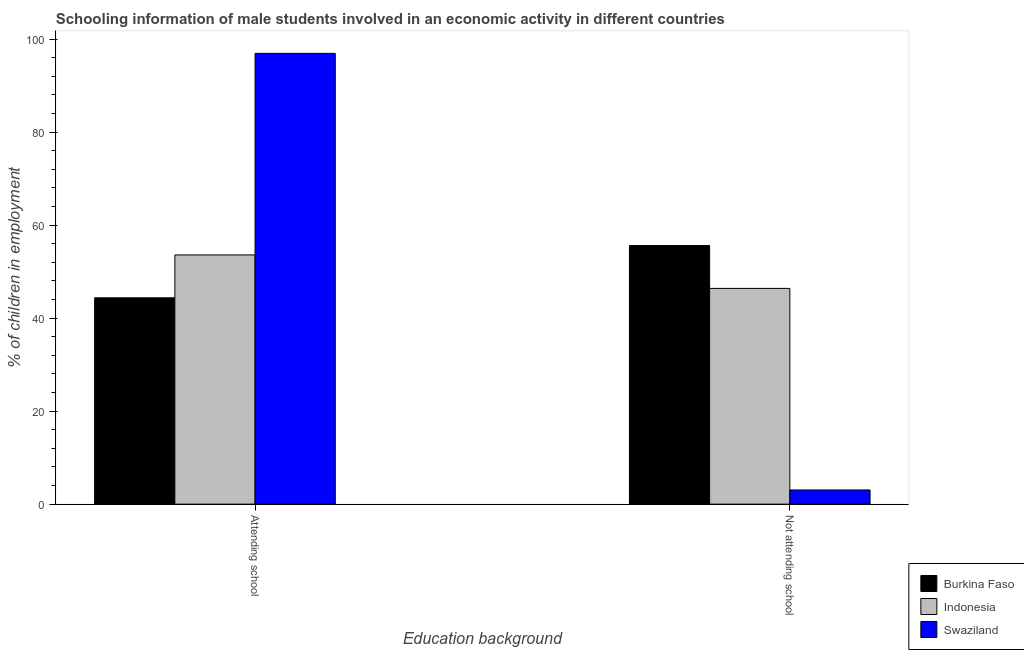How many different coloured bars are there?
Provide a short and direct response. 3. How many groups of bars are there?
Keep it short and to the point. 2. Are the number of bars per tick equal to the number of legend labels?
Your response must be concise. Yes. Are the number of bars on each tick of the X-axis equal?
Your response must be concise. Yes. How many bars are there on the 2nd tick from the left?
Your answer should be very brief. 3. What is the label of the 2nd group of bars from the left?
Your answer should be very brief. Not attending school. What is the percentage of employed males who are not attending school in Burkina Faso?
Offer a very short reply. 55.62. Across all countries, what is the maximum percentage of employed males who are attending school?
Keep it short and to the point. 96.95. Across all countries, what is the minimum percentage of employed males who are attending school?
Give a very brief answer. 44.38. In which country was the percentage of employed males who are attending school maximum?
Provide a succinct answer. Swaziland. In which country was the percentage of employed males who are attending school minimum?
Offer a terse response. Burkina Faso. What is the total percentage of employed males who are attending school in the graph?
Give a very brief answer. 194.93. What is the difference between the percentage of employed males who are not attending school in Indonesia and that in Swaziland?
Offer a terse response. 43.35. What is the difference between the percentage of employed males who are not attending school in Burkina Faso and the percentage of employed males who are attending school in Indonesia?
Provide a succinct answer. 2.02. What is the average percentage of employed males who are attending school per country?
Your response must be concise. 64.98. What is the difference between the percentage of employed males who are not attending school and percentage of employed males who are attending school in Swaziland?
Make the answer very short. -93.9. What is the ratio of the percentage of employed males who are not attending school in Burkina Faso to that in Indonesia?
Offer a very short reply. 1.2. Is the percentage of employed males who are not attending school in Indonesia less than that in Swaziland?
Give a very brief answer. No. What does the 3rd bar from the left in Attending school represents?
Provide a short and direct response. Swaziland. What does the 3rd bar from the right in Not attending school represents?
Ensure brevity in your answer.  Burkina Faso. How many bars are there?
Make the answer very short. 6. Are the values on the major ticks of Y-axis written in scientific E-notation?
Keep it short and to the point. No. Does the graph contain any zero values?
Your answer should be compact. No. Does the graph contain grids?
Your response must be concise. No. What is the title of the graph?
Offer a terse response. Schooling information of male students involved in an economic activity in different countries. Does "East Asia (all income levels)" appear as one of the legend labels in the graph?
Ensure brevity in your answer.  No. What is the label or title of the X-axis?
Give a very brief answer. Education background. What is the label or title of the Y-axis?
Your answer should be compact. % of children in employment. What is the % of children in employment in Burkina Faso in Attending school?
Ensure brevity in your answer.  44.38. What is the % of children in employment in Indonesia in Attending school?
Your response must be concise. 53.6. What is the % of children in employment in Swaziland in Attending school?
Provide a short and direct response. 96.95. What is the % of children in employment in Burkina Faso in Not attending school?
Your answer should be compact. 55.62. What is the % of children in employment of Indonesia in Not attending school?
Give a very brief answer. 46.4. What is the % of children in employment of Swaziland in Not attending school?
Your answer should be compact. 3.05. Across all Education background, what is the maximum % of children in employment in Burkina Faso?
Provide a succinct answer. 55.62. Across all Education background, what is the maximum % of children in employment of Indonesia?
Your answer should be very brief. 53.6. Across all Education background, what is the maximum % of children in employment of Swaziland?
Your response must be concise. 96.95. Across all Education background, what is the minimum % of children in employment in Burkina Faso?
Offer a very short reply. 44.38. Across all Education background, what is the minimum % of children in employment of Indonesia?
Ensure brevity in your answer.  46.4. Across all Education background, what is the minimum % of children in employment in Swaziland?
Give a very brief answer. 3.05. What is the total % of children in employment of Burkina Faso in the graph?
Offer a terse response. 100. What is the difference between the % of children in employment of Burkina Faso in Attending school and that in Not attending school?
Your response must be concise. -11.24. What is the difference between the % of children in employment in Swaziland in Attending school and that in Not attending school?
Ensure brevity in your answer.  93.9. What is the difference between the % of children in employment in Burkina Faso in Attending school and the % of children in employment in Indonesia in Not attending school?
Provide a succinct answer. -2.02. What is the difference between the % of children in employment of Burkina Faso in Attending school and the % of children in employment of Swaziland in Not attending school?
Your response must be concise. 41.33. What is the difference between the % of children in employment in Indonesia in Attending school and the % of children in employment in Swaziland in Not attending school?
Give a very brief answer. 50.55. What is the average % of children in employment of Indonesia per Education background?
Provide a short and direct response. 50. What is the difference between the % of children in employment in Burkina Faso and % of children in employment in Indonesia in Attending school?
Your response must be concise. -9.22. What is the difference between the % of children in employment of Burkina Faso and % of children in employment of Swaziland in Attending school?
Keep it short and to the point. -52.57. What is the difference between the % of children in employment of Indonesia and % of children in employment of Swaziland in Attending school?
Your answer should be compact. -43.35. What is the difference between the % of children in employment in Burkina Faso and % of children in employment in Indonesia in Not attending school?
Offer a very short reply. 9.22. What is the difference between the % of children in employment of Burkina Faso and % of children in employment of Swaziland in Not attending school?
Make the answer very short. 52.57. What is the difference between the % of children in employment in Indonesia and % of children in employment in Swaziland in Not attending school?
Provide a succinct answer. 43.35. What is the ratio of the % of children in employment of Burkina Faso in Attending school to that in Not attending school?
Give a very brief answer. 0.8. What is the ratio of the % of children in employment in Indonesia in Attending school to that in Not attending school?
Your answer should be compact. 1.16. What is the ratio of the % of children in employment in Swaziland in Attending school to that in Not attending school?
Your answer should be compact. 31.77. What is the difference between the highest and the second highest % of children in employment of Burkina Faso?
Give a very brief answer. 11.24. What is the difference between the highest and the second highest % of children in employment in Swaziland?
Your response must be concise. 93.9. What is the difference between the highest and the lowest % of children in employment of Burkina Faso?
Offer a terse response. 11.24. What is the difference between the highest and the lowest % of children in employment in Swaziland?
Ensure brevity in your answer.  93.9. 